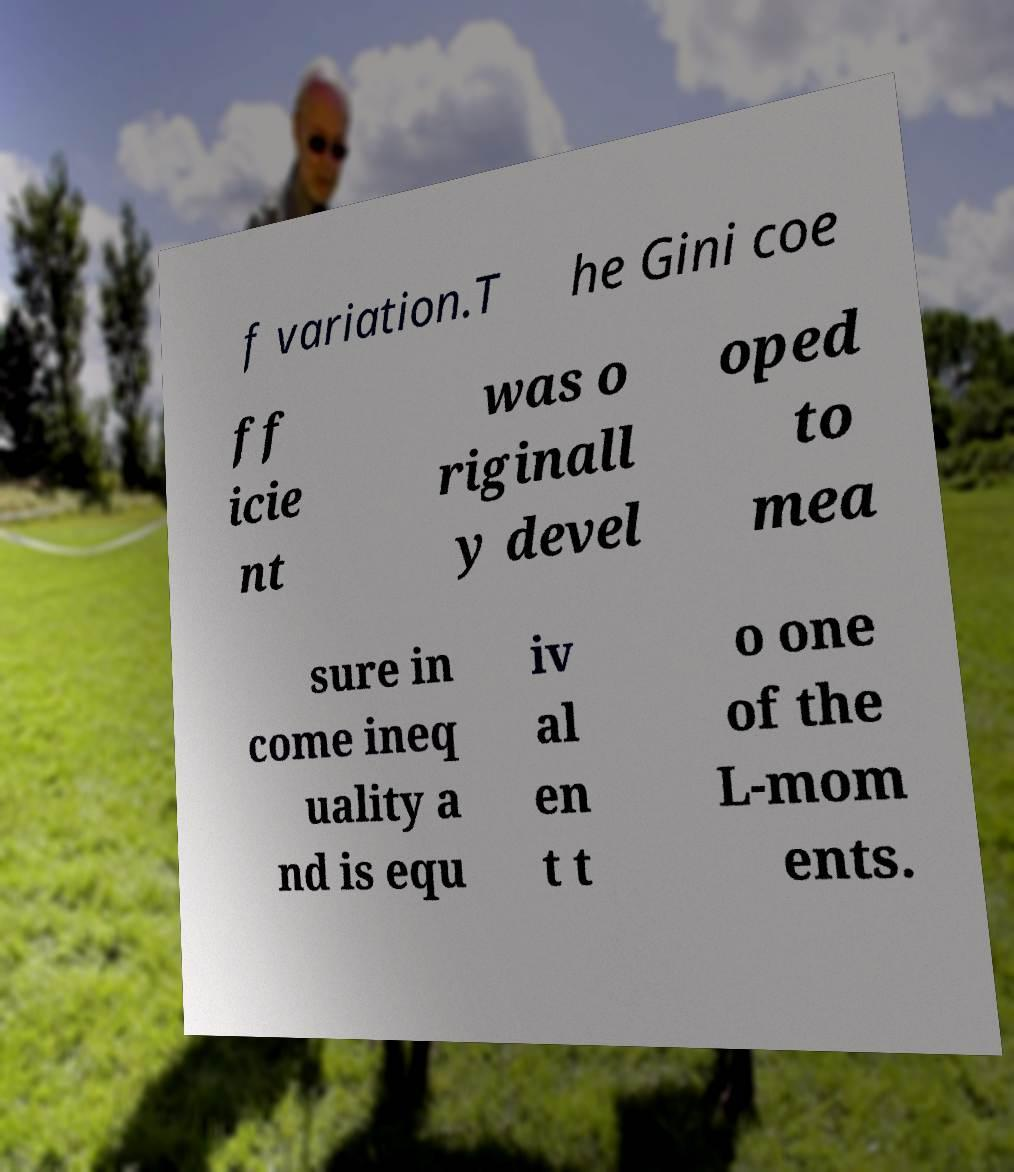Can you read and provide the text displayed in the image?This photo seems to have some interesting text. Can you extract and type it out for me? f variation.T he Gini coe ff icie nt was o riginall y devel oped to mea sure in come ineq uality a nd is equ iv al en t t o one of the L-mom ents. 